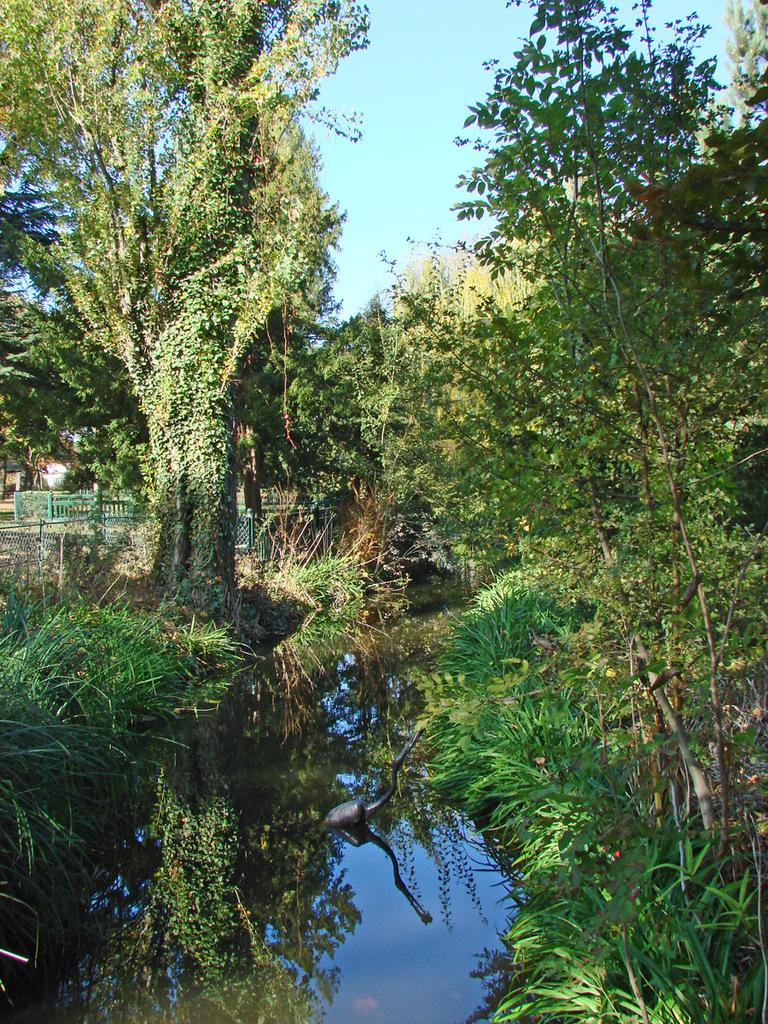What is present at the bottom of the image? There is water at the bottom of the image. What can be seen in the background of the image? There are many trees in the background of the image. What is visible at the top of the image? The sky is visible at the top of the image. Where is the brake located in the image? There is no brake present in the image. What type of wall can be seen in the image? There is no wall present in the image. 